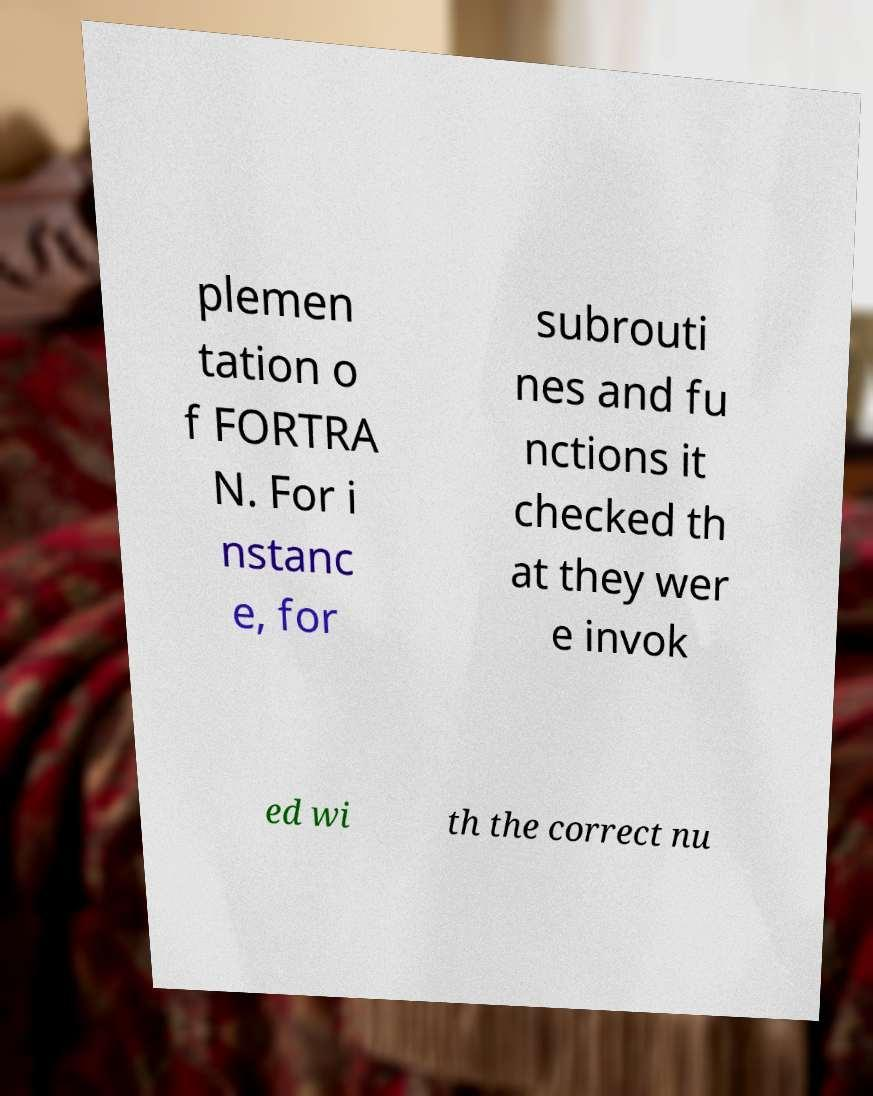Could you extract and type out the text from this image? plemen tation o f FORTRA N. For i nstanc e, for subrouti nes and fu nctions it checked th at they wer e invok ed wi th the correct nu 